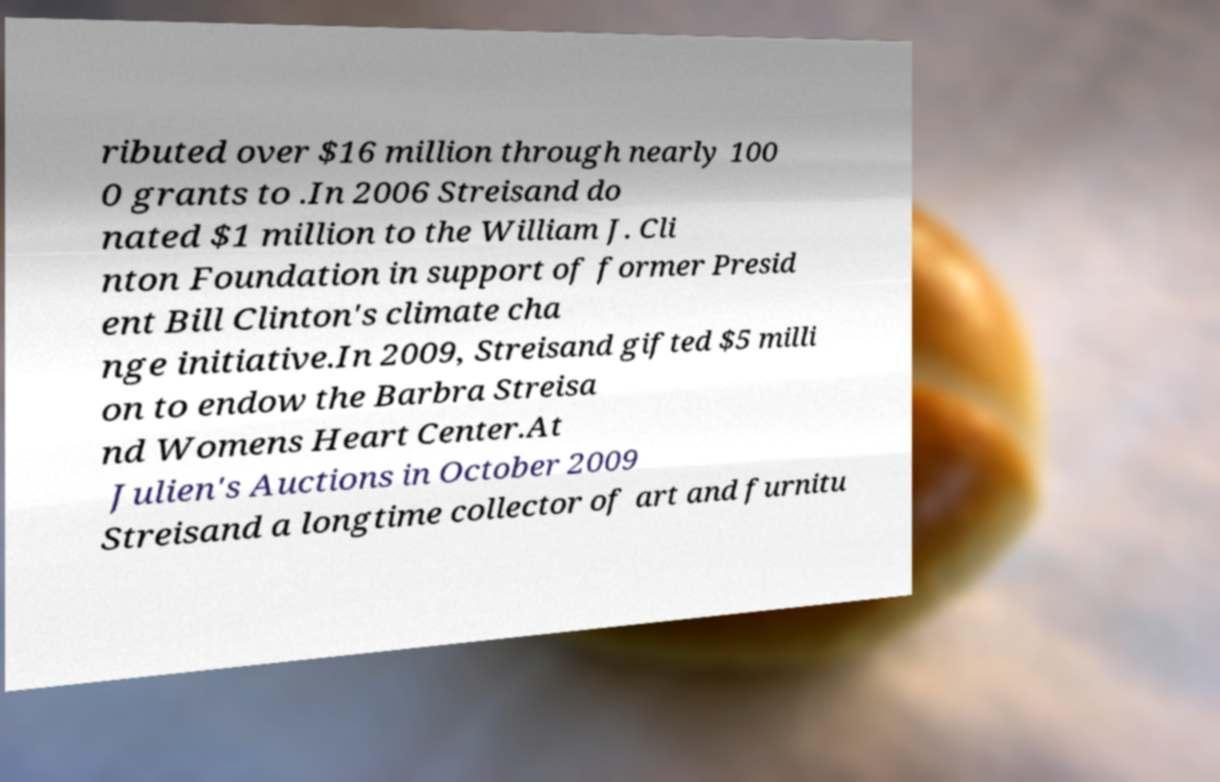I need the written content from this picture converted into text. Can you do that? ributed over $16 million through nearly 100 0 grants to .In 2006 Streisand do nated $1 million to the William J. Cli nton Foundation in support of former Presid ent Bill Clinton's climate cha nge initiative.In 2009, Streisand gifted $5 milli on to endow the Barbra Streisa nd Womens Heart Center.At Julien's Auctions in October 2009 Streisand a longtime collector of art and furnitu 